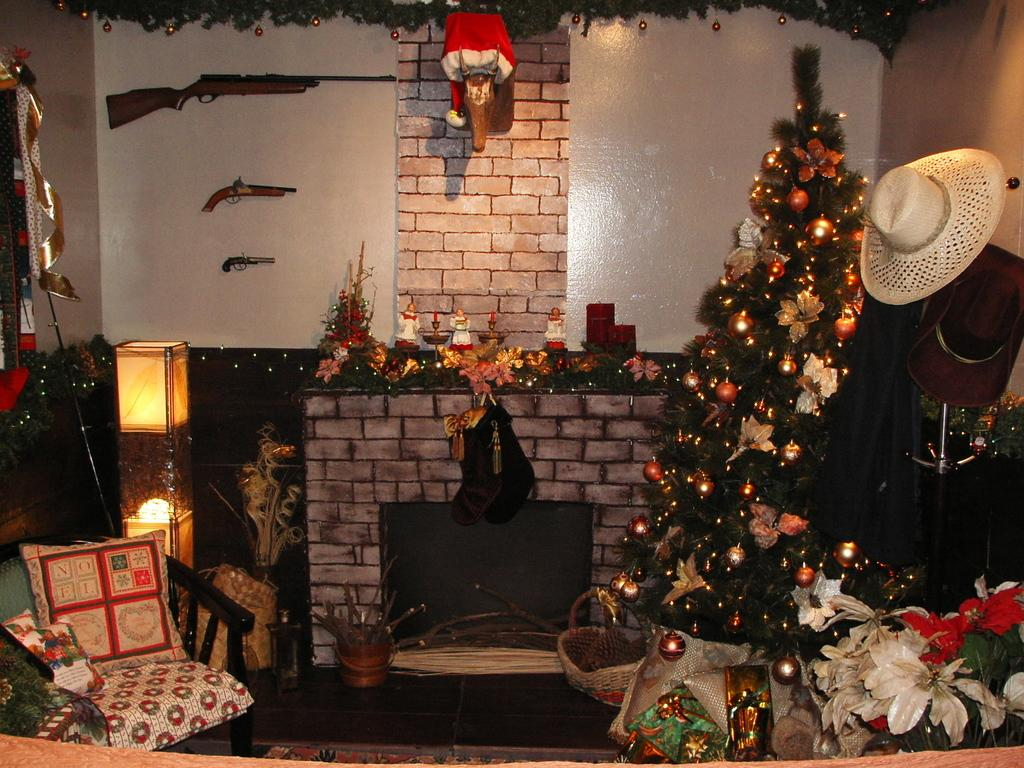What type of tree is in the room? There is a Christmas tree in the room. What items are hanging on the wall? There are hats and guns on the wall. What type of cap is in the room? There is a Santa Claus cap in the room. What is on the chair in the room? There is a pillow on the chair. What type of lighting is present in the room? There are lights in the room. What electronic device is in the room? There is a TV in the room. What songs are being sung by the steam in the room? There is no steam present in the room, so no songs can be sung by it. How does the attack on the Christmas tree occur in the room? There is no attack on the Christmas tree in the room; it is a decorative item. 